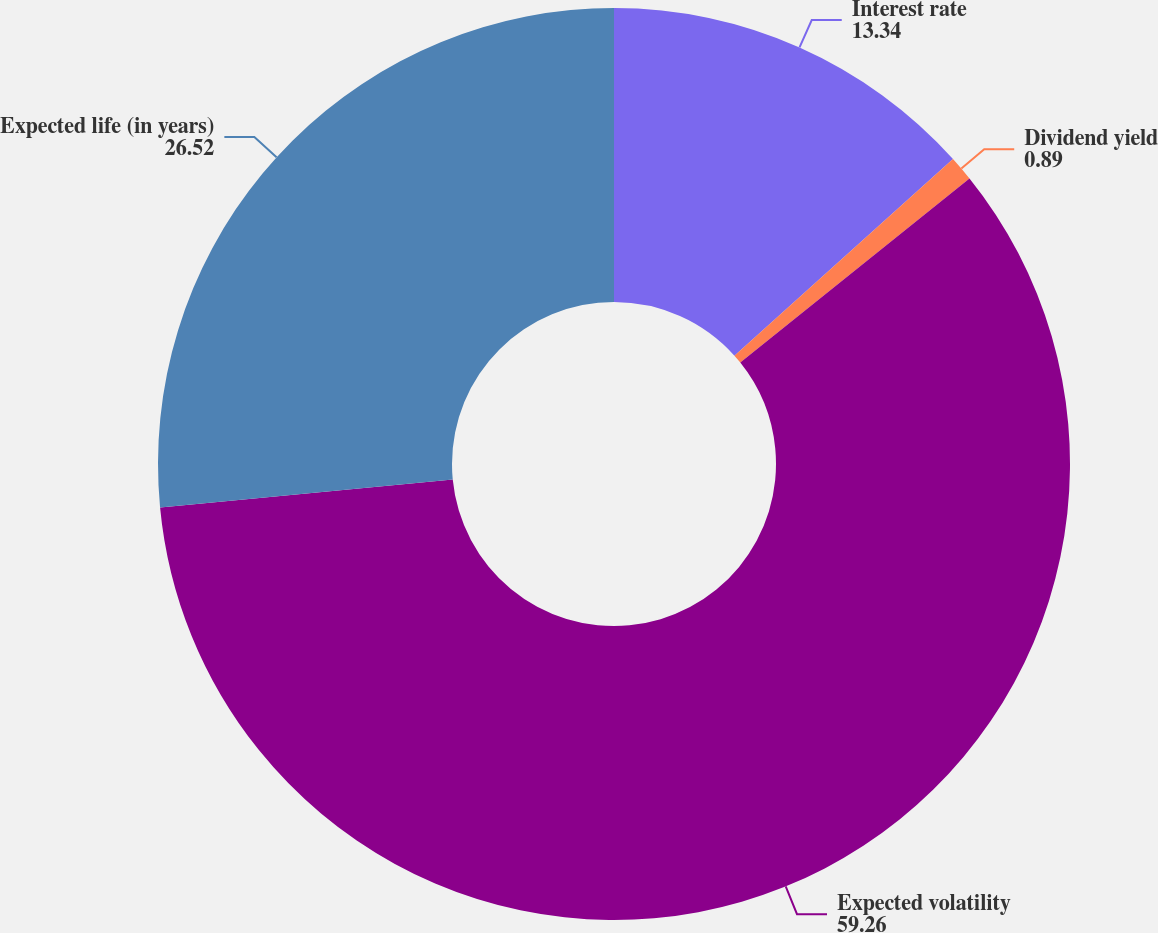Convert chart to OTSL. <chart><loc_0><loc_0><loc_500><loc_500><pie_chart><fcel>Interest rate<fcel>Dividend yield<fcel>Expected volatility<fcel>Expected life (in years)<nl><fcel>13.34%<fcel>0.89%<fcel>59.26%<fcel>26.52%<nl></chart> 